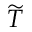<formula> <loc_0><loc_0><loc_500><loc_500>\widetilde { T }</formula> 